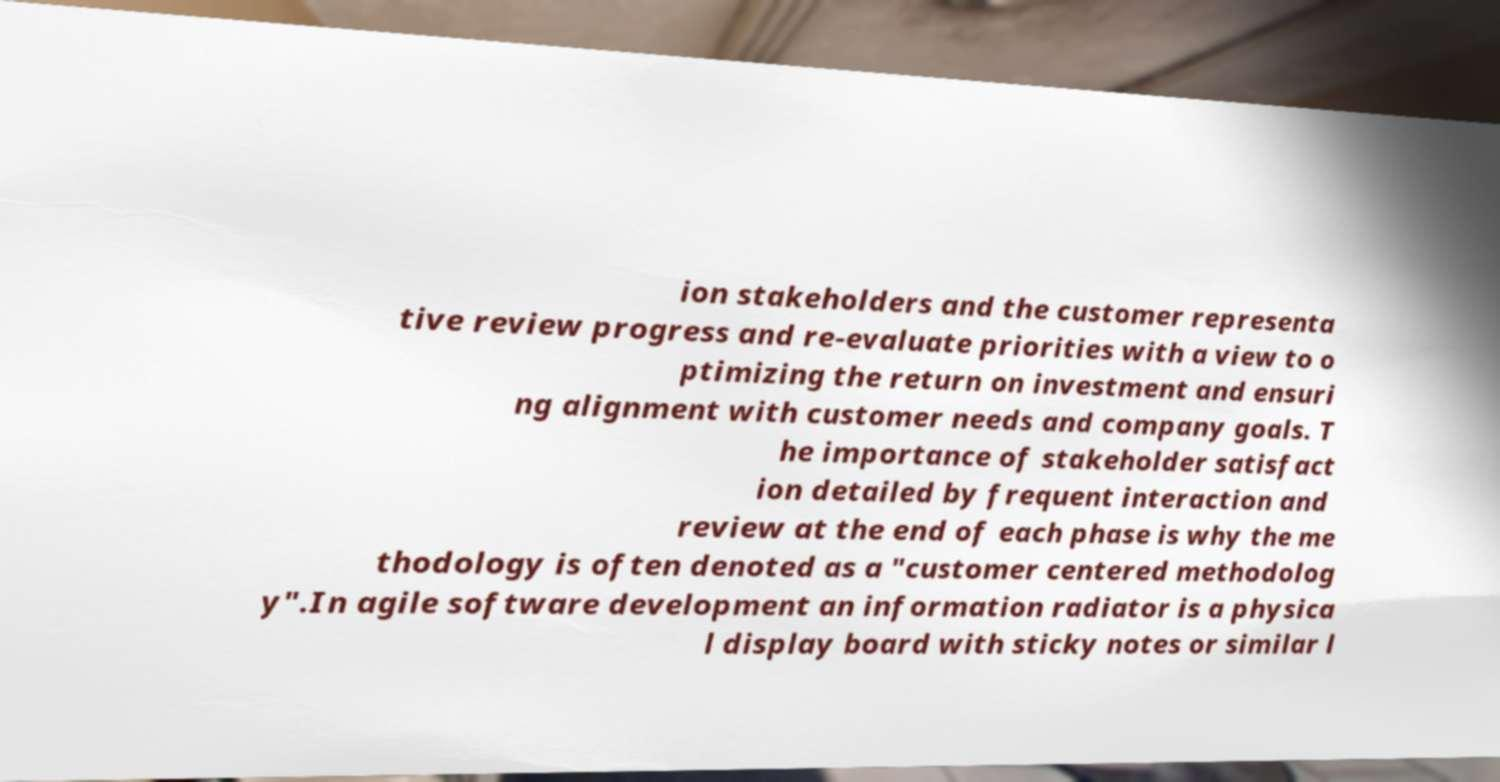For documentation purposes, I need the text within this image transcribed. Could you provide that? ion stakeholders and the customer representa tive review progress and re-evaluate priorities with a view to o ptimizing the return on investment and ensuri ng alignment with customer needs and company goals. T he importance of stakeholder satisfact ion detailed by frequent interaction and review at the end of each phase is why the me thodology is often denoted as a "customer centered methodolog y".In agile software development an information radiator is a physica l display board with sticky notes or similar l 